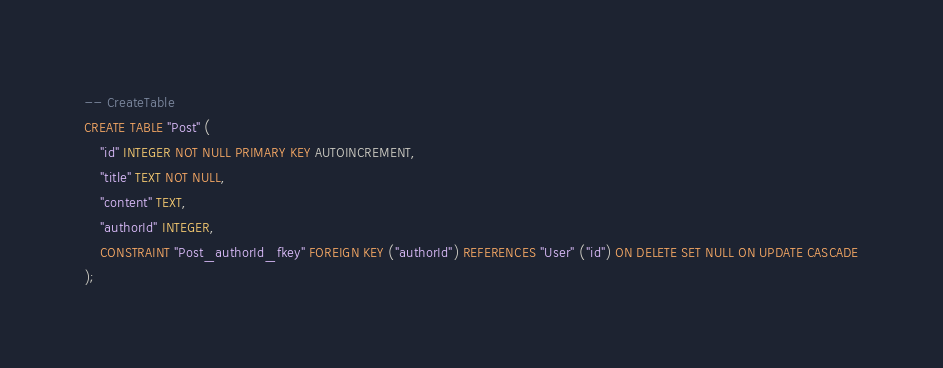<code> <loc_0><loc_0><loc_500><loc_500><_SQL_>-- CreateTable
CREATE TABLE "Post" (
    "id" INTEGER NOT NULL PRIMARY KEY AUTOINCREMENT,
    "title" TEXT NOT NULL,
    "content" TEXT,
    "authorId" INTEGER,
    CONSTRAINT "Post_authorId_fkey" FOREIGN KEY ("authorId") REFERENCES "User" ("id") ON DELETE SET NULL ON UPDATE CASCADE
);
</code> 